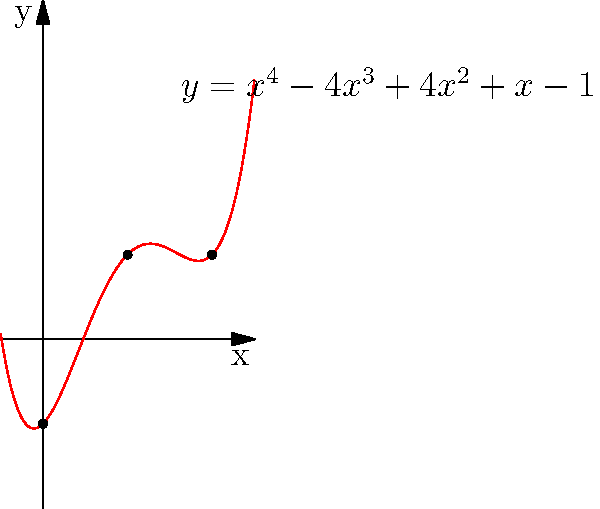Consider the polynomial function $f(x) = x^4 - 4x^3 + 4x^2 + x - 1$, whose graph is shown above. How many turning points does this function have, and what is the relationship between the number of turning points and the degree of the polynomial? To answer this question, let's follow these steps:

1) First, recall that the maximum number of turning points for a polynomial of degree $n$ is $n-1$.

2) In this case, we have a 4th-degree polynomial (quartic function), so the maximum number of turning points is 3.

3) To find the actual number of turning points, we need to find the local maxima and minima of the function. These occur where the first derivative $f'(x)$ is zero or undefined.

4) The first derivative of $f(x)$ is:
   $f'(x) = 4x^3 - 12x^2 + 8x + 1$

5) Setting this equal to zero:
   $4x^3 - 12x^2 + 8x + 1 = 0$

6) This cubic equation has at most 3 real roots, corresponding to the potential turning points of $f(x)$.

7) From the graph, we can see that there are indeed 3 turning points: two local minima and one local maximum.

8) This confirms that this 4th-degree polynomial achieves the maximum possible number of turning points (3).

9) The relationship between the degree of the polynomial (4) and the number of turning points (3) is: number of turning points = degree - 1.
Answer: 3 turning points; number of turning points = degree - 1 